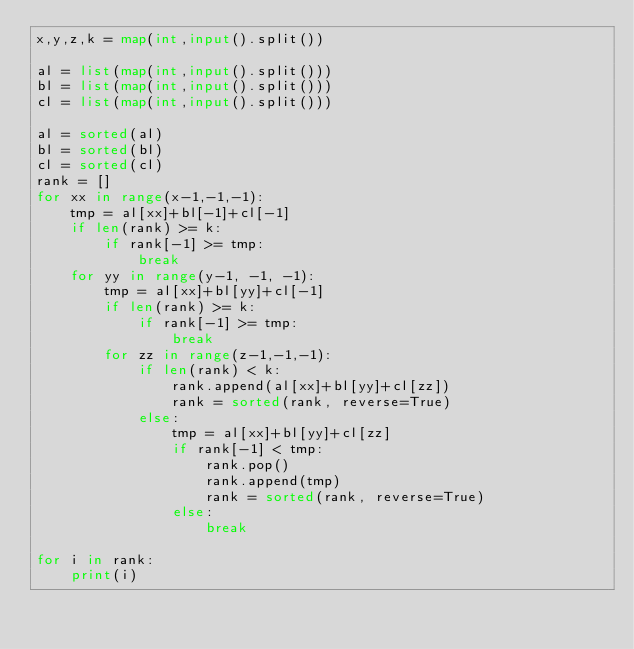Convert code to text. <code><loc_0><loc_0><loc_500><loc_500><_Python_>x,y,z,k = map(int,input().split())	

al = list(map(int,input().split()))
bl = list(map(int,input().split()))
cl = list(map(int,input().split()))

al = sorted(al)
bl = sorted(bl)
cl = sorted(cl)
rank = []
for xx in range(x-1,-1,-1):
    tmp = al[xx]+bl[-1]+cl[-1]
    if len(rank) >= k:
        if rank[-1] >= tmp:
            break
    for yy in range(y-1, -1, -1):
        tmp = al[xx]+bl[yy]+cl[-1]
        if len(rank) >= k:
            if rank[-1] >= tmp:
                break
        for zz in range(z-1,-1,-1):
            if len(rank) < k:
                rank.append(al[xx]+bl[yy]+cl[zz])
                rank = sorted(rank, reverse=True)
            else:
                tmp = al[xx]+bl[yy]+cl[zz]
                if rank[-1] < tmp:
                    rank.pop()
                    rank.append(tmp)
                    rank = sorted(rank, reverse=True)
                else:
                    break

for i in rank:
    print(i)
                
            
            </code> 